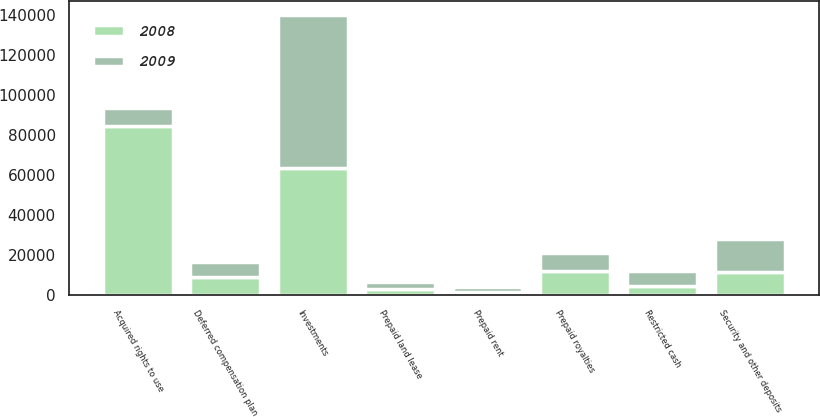Convert chart. <chart><loc_0><loc_0><loc_500><loc_500><stacked_bar_chart><ecel><fcel>Acquired rights to use<fcel>Investments<fcel>Security and other deposits<fcel>Prepaid royalties<fcel>Deferred compensation plan<fcel>Restricted cash<fcel>Prepaid land lease<fcel>Prepaid rent<nl><fcel>2008<fcel>84313<fcel>63526<fcel>11692<fcel>12059<fcel>9045<fcel>4650<fcel>3209<fcel>1377<nl><fcel>2009<fcel>9026<fcel>76589<fcel>16087<fcel>9026<fcel>7560<fcel>7361<fcel>3185<fcel>2658<nl></chart> 